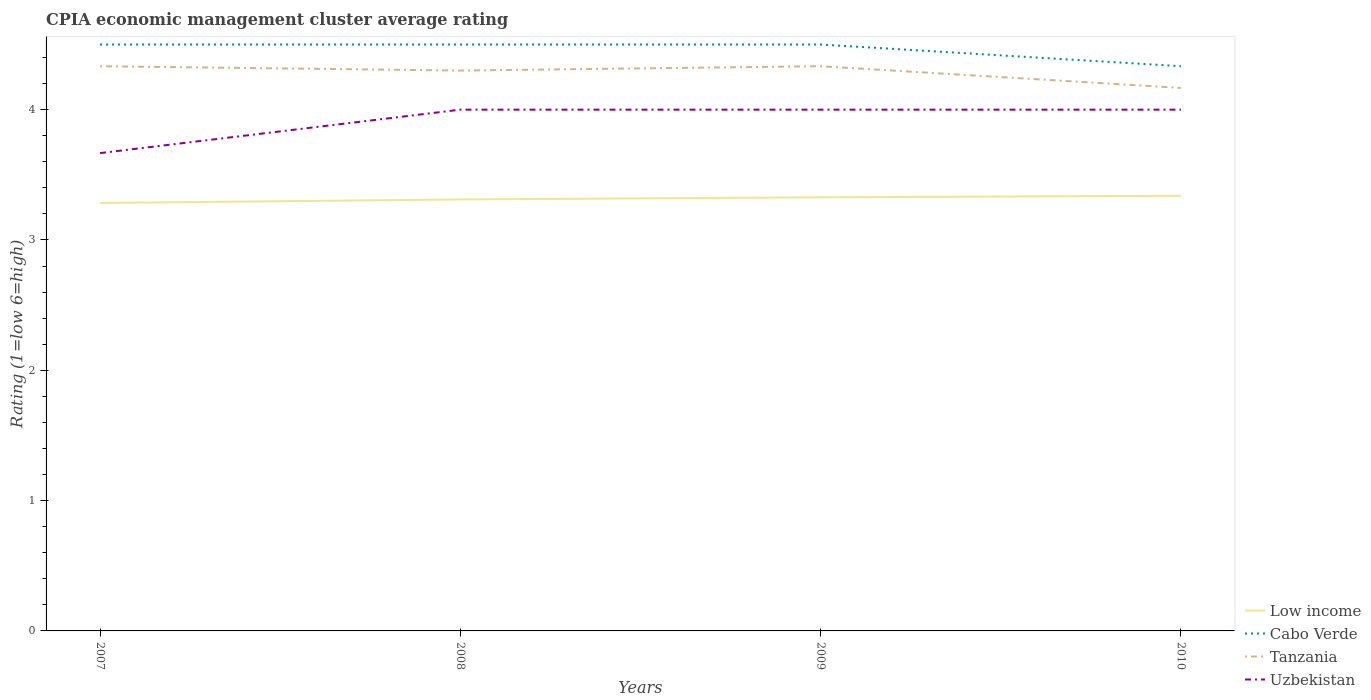How many different coloured lines are there?
Offer a very short reply. 4. Does the line corresponding to Uzbekistan intersect with the line corresponding to Cabo Verde?
Your answer should be very brief. No. Is the number of lines equal to the number of legend labels?
Give a very brief answer. Yes. Across all years, what is the maximum CPIA rating in Low income?
Your answer should be very brief. 3.28. What is the total CPIA rating in Low income in the graph?
Keep it short and to the point. -0.06. What is the difference between the highest and the second highest CPIA rating in Uzbekistan?
Keep it short and to the point. 0.33. How many lines are there?
Your response must be concise. 4. What is the difference between two consecutive major ticks on the Y-axis?
Offer a very short reply. 1. Are the values on the major ticks of Y-axis written in scientific E-notation?
Ensure brevity in your answer.  No. Does the graph contain grids?
Provide a succinct answer. No. Where does the legend appear in the graph?
Provide a short and direct response. Bottom right. What is the title of the graph?
Your response must be concise. CPIA economic management cluster average rating. What is the label or title of the X-axis?
Give a very brief answer. Years. What is the Rating (1=low 6=high) in Low income in 2007?
Keep it short and to the point. 3.28. What is the Rating (1=low 6=high) of Tanzania in 2007?
Your answer should be compact. 4.33. What is the Rating (1=low 6=high) in Uzbekistan in 2007?
Keep it short and to the point. 3.67. What is the Rating (1=low 6=high) of Low income in 2008?
Your answer should be very brief. 3.31. What is the Rating (1=low 6=high) in Cabo Verde in 2008?
Provide a short and direct response. 4.5. What is the Rating (1=low 6=high) in Tanzania in 2008?
Provide a short and direct response. 4.3. What is the Rating (1=low 6=high) of Uzbekistan in 2008?
Ensure brevity in your answer.  4. What is the Rating (1=low 6=high) in Low income in 2009?
Give a very brief answer. 3.33. What is the Rating (1=low 6=high) in Cabo Verde in 2009?
Ensure brevity in your answer.  4.5. What is the Rating (1=low 6=high) in Tanzania in 2009?
Make the answer very short. 4.33. What is the Rating (1=low 6=high) in Uzbekistan in 2009?
Make the answer very short. 4. What is the Rating (1=low 6=high) in Low income in 2010?
Make the answer very short. 3.34. What is the Rating (1=low 6=high) in Cabo Verde in 2010?
Provide a short and direct response. 4.33. What is the Rating (1=low 6=high) of Tanzania in 2010?
Your answer should be very brief. 4.17. Across all years, what is the maximum Rating (1=low 6=high) of Low income?
Your answer should be compact. 3.34. Across all years, what is the maximum Rating (1=low 6=high) in Tanzania?
Offer a terse response. 4.33. Across all years, what is the maximum Rating (1=low 6=high) of Uzbekistan?
Provide a succinct answer. 4. Across all years, what is the minimum Rating (1=low 6=high) in Low income?
Offer a very short reply. 3.28. Across all years, what is the minimum Rating (1=low 6=high) of Cabo Verde?
Give a very brief answer. 4.33. Across all years, what is the minimum Rating (1=low 6=high) in Tanzania?
Give a very brief answer. 4.17. Across all years, what is the minimum Rating (1=low 6=high) of Uzbekistan?
Your answer should be compact. 3.67. What is the total Rating (1=low 6=high) of Low income in the graph?
Your answer should be very brief. 13.26. What is the total Rating (1=low 6=high) in Cabo Verde in the graph?
Provide a short and direct response. 17.83. What is the total Rating (1=low 6=high) of Tanzania in the graph?
Give a very brief answer. 17.13. What is the total Rating (1=low 6=high) in Uzbekistan in the graph?
Make the answer very short. 15.67. What is the difference between the Rating (1=low 6=high) in Low income in 2007 and that in 2008?
Ensure brevity in your answer.  -0.03. What is the difference between the Rating (1=low 6=high) of Tanzania in 2007 and that in 2008?
Offer a terse response. 0.03. What is the difference between the Rating (1=low 6=high) of Low income in 2007 and that in 2009?
Your response must be concise. -0.04. What is the difference between the Rating (1=low 6=high) in Cabo Verde in 2007 and that in 2009?
Ensure brevity in your answer.  0. What is the difference between the Rating (1=low 6=high) in Tanzania in 2007 and that in 2009?
Provide a short and direct response. 0. What is the difference between the Rating (1=low 6=high) in Uzbekistan in 2007 and that in 2009?
Offer a terse response. -0.33. What is the difference between the Rating (1=low 6=high) in Low income in 2007 and that in 2010?
Ensure brevity in your answer.  -0.06. What is the difference between the Rating (1=low 6=high) of Uzbekistan in 2007 and that in 2010?
Your answer should be compact. -0.33. What is the difference between the Rating (1=low 6=high) of Low income in 2008 and that in 2009?
Your answer should be compact. -0.02. What is the difference between the Rating (1=low 6=high) of Tanzania in 2008 and that in 2009?
Provide a succinct answer. -0.03. What is the difference between the Rating (1=low 6=high) in Low income in 2008 and that in 2010?
Your answer should be very brief. -0.03. What is the difference between the Rating (1=low 6=high) of Cabo Verde in 2008 and that in 2010?
Your response must be concise. 0.17. What is the difference between the Rating (1=low 6=high) in Tanzania in 2008 and that in 2010?
Your answer should be very brief. 0.13. What is the difference between the Rating (1=low 6=high) in Uzbekistan in 2008 and that in 2010?
Your answer should be very brief. 0. What is the difference between the Rating (1=low 6=high) in Low income in 2009 and that in 2010?
Keep it short and to the point. -0.01. What is the difference between the Rating (1=low 6=high) of Tanzania in 2009 and that in 2010?
Make the answer very short. 0.17. What is the difference between the Rating (1=low 6=high) of Low income in 2007 and the Rating (1=low 6=high) of Cabo Verde in 2008?
Give a very brief answer. -1.22. What is the difference between the Rating (1=low 6=high) in Low income in 2007 and the Rating (1=low 6=high) in Tanzania in 2008?
Your response must be concise. -1.02. What is the difference between the Rating (1=low 6=high) of Low income in 2007 and the Rating (1=low 6=high) of Uzbekistan in 2008?
Ensure brevity in your answer.  -0.72. What is the difference between the Rating (1=low 6=high) in Cabo Verde in 2007 and the Rating (1=low 6=high) in Uzbekistan in 2008?
Give a very brief answer. 0.5. What is the difference between the Rating (1=low 6=high) in Low income in 2007 and the Rating (1=low 6=high) in Cabo Verde in 2009?
Your response must be concise. -1.22. What is the difference between the Rating (1=low 6=high) of Low income in 2007 and the Rating (1=low 6=high) of Tanzania in 2009?
Give a very brief answer. -1.05. What is the difference between the Rating (1=low 6=high) of Low income in 2007 and the Rating (1=low 6=high) of Uzbekistan in 2009?
Keep it short and to the point. -0.72. What is the difference between the Rating (1=low 6=high) of Low income in 2007 and the Rating (1=low 6=high) of Cabo Verde in 2010?
Ensure brevity in your answer.  -1.05. What is the difference between the Rating (1=low 6=high) in Low income in 2007 and the Rating (1=low 6=high) in Tanzania in 2010?
Provide a succinct answer. -0.88. What is the difference between the Rating (1=low 6=high) of Low income in 2007 and the Rating (1=low 6=high) of Uzbekistan in 2010?
Provide a short and direct response. -0.72. What is the difference between the Rating (1=low 6=high) in Low income in 2008 and the Rating (1=low 6=high) in Cabo Verde in 2009?
Offer a very short reply. -1.19. What is the difference between the Rating (1=low 6=high) of Low income in 2008 and the Rating (1=low 6=high) of Tanzania in 2009?
Make the answer very short. -1.02. What is the difference between the Rating (1=low 6=high) in Low income in 2008 and the Rating (1=low 6=high) in Uzbekistan in 2009?
Keep it short and to the point. -0.69. What is the difference between the Rating (1=low 6=high) in Cabo Verde in 2008 and the Rating (1=low 6=high) in Tanzania in 2009?
Offer a very short reply. 0.17. What is the difference between the Rating (1=low 6=high) in Cabo Verde in 2008 and the Rating (1=low 6=high) in Uzbekistan in 2009?
Your response must be concise. 0.5. What is the difference between the Rating (1=low 6=high) of Low income in 2008 and the Rating (1=low 6=high) of Cabo Verde in 2010?
Provide a succinct answer. -1.02. What is the difference between the Rating (1=low 6=high) of Low income in 2008 and the Rating (1=low 6=high) of Tanzania in 2010?
Offer a very short reply. -0.86. What is the difference between the Rating (1=low 6=high) in Low income in 2008 and the Rating (1=low 6=high) in Uzbekistan in 2010?
Make the answer very short. -0.69. What is the difference between the Rating (1=low 6=high) in Cabo Verde in 2008 and the Rating (1=low 6=high) in Tanzania in 2010?
Offer a very short reply. 0.33. What is the difference between the Rating (1=low 6=high) in Cabo Verde in 2008 and the Rating (1=low 6=high) in Uzbekistan in 2010?
Offer a very short reply. 0.5. What is the difference between the Rating (1=low 6=high) in Low income in 2009 and the Rating (1=low 6=high) in Cabo Verde in 2010?
Ensure brevity in your answer.  -1.01. What is the difference between the Rating (1=low 6=high) of Low income in 2009 and the Rating (1=low 6=high) of Tanzania in 2010?
Offer a terse response. -0.84. What is the difference between the Rating (1=low 6=high) in Low income in 2009 and the Rating (1=low 6=high) in Uzbekistan in 2010?
Keep it short and to the point. -0.67. What is the difference between the Rating (1=low 6=high) of Cabo Verde in 2009 and the Rating (1=low 6=high) of Uzbekistan in 2010?
Your answer should be compact. 0.5. What is the difference between the Rating (1=low 6=high) in Tanzania in 2009 and the Rating (1=low 6=high) in Uzbekistan in 2010?
Offer a terse response. 0.33. What is the average Rating (1=low 6=high) of Low income per year?
Give a very brief answer. 3.32. What is the average Rating (1=low 6=high) in Cabo Verde per year?
Ensure brevity in your answer.  4.46. What is the average Rating (1=low 6=high) of Tanzania per year?
Give a very brief answer. 4.28. What is the average Rating (1=low 6=high) of Uzbekistan per year?
Provide a succinct answer. 3.92. In the year 2007, what is the difference between the Rating (1=low 6=high) of Low income and Rating (1=low 6=high) of Cabo Verde?
Make the answer very short. -1.22. In the year 2007, what is the difference between the Rating (1=low 6=high) of Low income and Rating (1=low 6=high) of Tanzania?
Offer a terse response. -1.05. In the year 2007, what is the difference between the Rating (1=low 6=high) of Low income and Rating (1=low 6=high) of Uzbekistan?
Your answer should be very brief. -0.38. In the year 2007, what is the difference between the Rating (1=low 6=high) in Cabo Verde and Rating (1=low 6=high) in Uzbekistan?
Offer a terse response. 0.83. In the year 2008, what is the difference between the Rating (1=low 6=high) in Low income and Rating (1=low 6=high) in Cabo Verde?
Make the answer very short. -1.19. In the year 2008, what is the difference between the Rating (1=low 6=high) of Low income and Rating (1=low 6=high) of Tanzania?
Provide a short and direct response. -0.99. In the year 2008, what is the difference between the Rating (1=low 6=high) in Low income and Rating (1=low 6=high) in Uzbekistan?
Ensure brevity in your answer.  -0.69. In the year 2008, what is the difference between the Rating (1=low 6=high) in Cabo Verde and Rating (1=low 6=high) in Tanzania?
Offer a very short reply. 0.2. In the year 2008, what is the difference between the Rating (1=low 6=high) in Tanzania and Rating (1=low 6=high) in Uzbekistan?
Offer a very short reply. 0.3. In the year 2009, what is the difference between the Rating (1=low 6=high) of Low income and Rating (1=low 6=high) of Cabo Verde?
Your response must be concise. -1.17. In the year 2009, what is the difference between the Rating (1=low 6=high) in Low income and Rating (1=low 6=high) in Tanzania?
Offer a very short reply. -1.01. In the year 2009, what is the difference between the Rating (1=low 6=high) in Low income and Rating (1=low 6=high) in Uzbekistan?
Provide a succinct answer. -0.67. In the year 2010, what is the difference between the Rating (1=low 6=high) in Low income and Rating (1=low 6=high) in Cabo Verde?
Make the answer very short. -0.99. In the year 2010, what is the difference between the Rating (1=low 6=high) in Low income and Rating (1=low 6=high) in Tanzania?
Give a very brief answer. -0.83. In the year 2010, what is the difference between the Rating (1=low 6=high) of Low income and Rating (1=low 6=high) of Uzbekistan?
Make the answer very short. -0.66. In the year 2010, what is the difference between the Rating (1=low 6=high) in Cabo Verde and Rating (1=low 6=high) in Tanzania?
Make the answer very short. 0.17. In the year 2010, what is the difference between the Rating (1=low 6=high) of Cabo Verde and Rating (1=low 6=high) of Uzbekistan?
Keep it short and to the point. 0.33. In the year 2010, what is the difference between the Rating (1=low 6=high) in Tanzania and Rating (1=low 6=high) in Uzbekistan?
Offer a terse response. 0.17. What is the ratio of the Rating (1=low 6=high) of Uzbekistan in 2007 to that in 2008?
Provide a succinct answer. 0.92. What is the ratio of the Rating (1=low 6=high) of Low income in 2007 to that in 2009?
Your answer should be very brief. 0.99. What is the ratio of the Rating (1=low 6=high) of Cabo Verde in 2007 to that in 2009?
Ensure brevity in your answer.  1. What is the ratio of the Rating (1=low 6=high) in Tanzania in 2007 to that in 2009?
Keep it short and to the point. 1. What is the ratio of the Rating (1=low 6=high) of Low income in 2007 to that in 2010?
Your answer should be very brief. 0.98. What is the ratio of the Rating (1=low 6=high) of Cabo Verde in 2007 to that in 2010?
Keep it short and to the point. 1.04. What is the ratio of the Rating (1=low 6=high) of Uzbekistan in 2007 to that in 2010?
Offer a terse response. 0.92. What is the ratio of the Rating (1=low 6=high) of Uzbekistan in 2008 to that in 2009?
Provide a short and direct response. 1. What is the ratio of the Rating (1=low 6=high) of Cabo Verde in 2008 to that in 2010?
Offer a terse response. 1.04. What is the ratio of the Rating (1=low 6=high) in Tanzania in 2008 to that in 2010?
Offer a terse response. 1.03. What is the ratio of the Rating (1=low 6=high) of Uzbekistan in 2008 to that in 2010?
Make the answer very short. 1. What is the ratio of the Rating (1=low 6=high) in Uzbekistan in 2009 to that in 2010?
Offer a very short reply. 1. What is the difference between the highest and the second highest Rating (1=low 6=high) in Low income?
Your answer should be compact. 0.01. What is the difference between the highest and the lowest Rating (1=low 6=high) in Low income?
Offer a terse response. 0.06. What is the difference between the highest and the lowest Rating (1=low 6=high) of Cabo Verde?
Your answer should be very brief. 0.17. What is the difference between the highest and the lowest Rating (1=low 6=high) of Uzbekistan?
Make the answer very short. 0.33. 